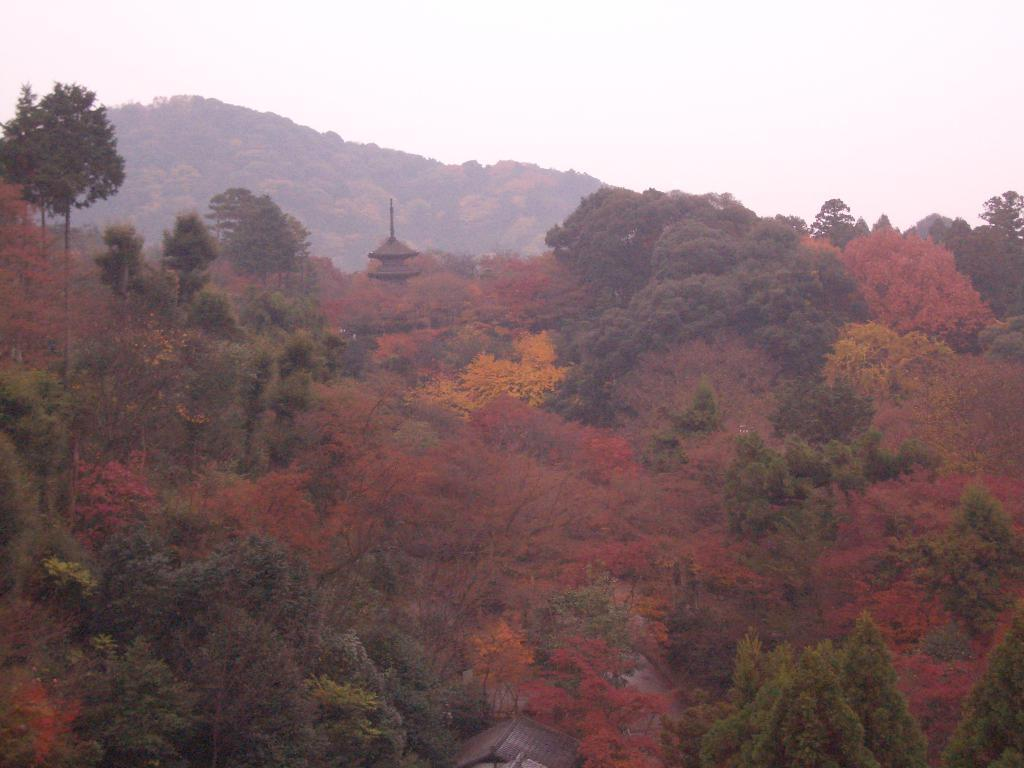What type of vegetation is present in the image? There is a group of trees in the image. What structure is located in the middle of the image? There is a house in the middle of the image. What natural feature can be seen behind the trees? There are mountains visible behind the trees. What type of buildings are at the bottom of the image? There are houses at the bottom of the image. What is visible at the top of the image? The sky is visible at the top of the image. How many kittens are playing with rings in the image? There are no kittens or rings present in the image. What role does the governor play in the image? There is no governor present in the image. 